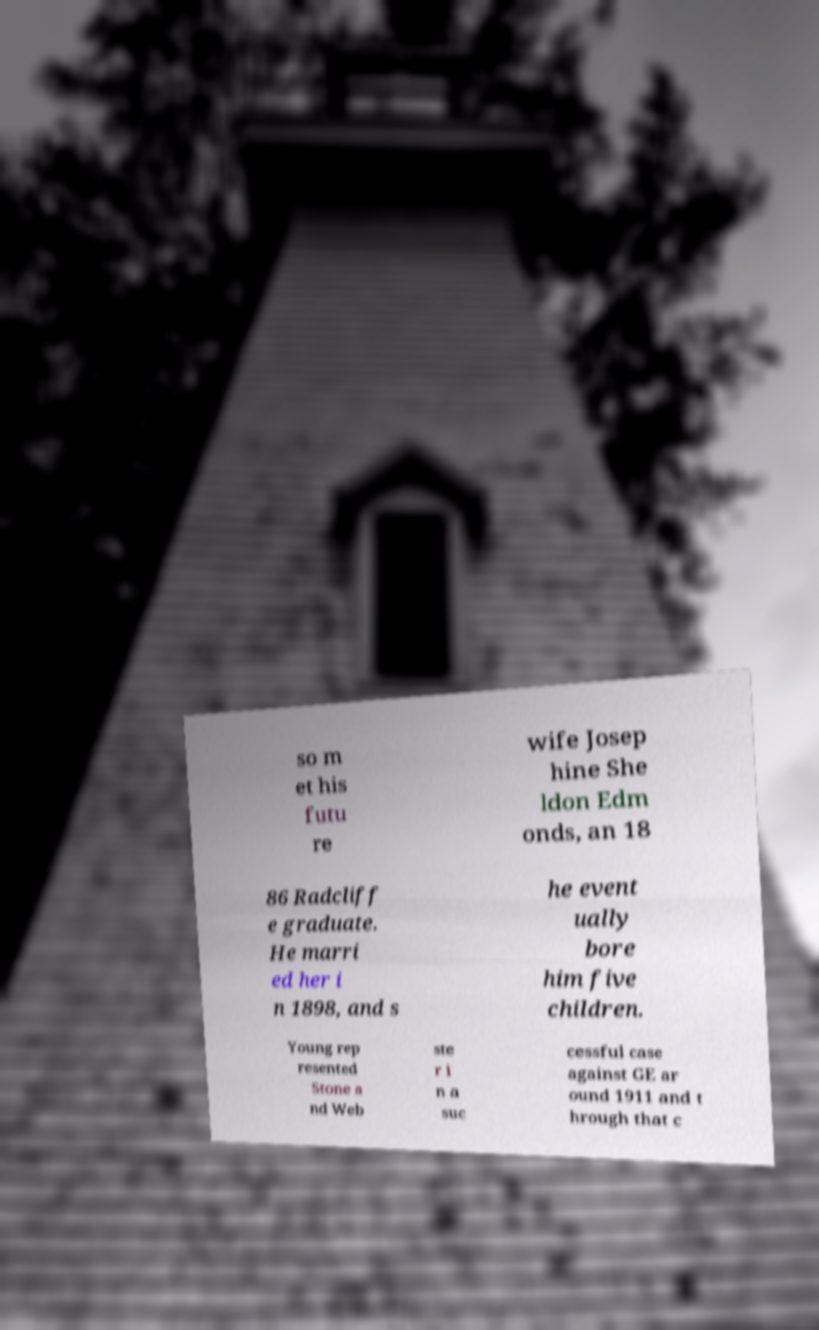Could you assist in decoding the text presented in this image and type it out clearly? so m et his futu re wife Josep hine She ldon Edm onds, an 18 86 Radcliff e graduate. He marri ed her i n 1898, and s he event ually bore him five children. Young rep resented Stone a nd Web ste r i n a suc cessful case against GE ar ound 1911 and t hrough that c 